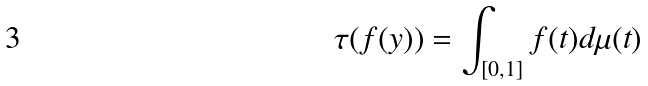<formula> <loc_0><loc_0><loc_500><loc_500>\tau ( f ( y ) ) = \int _ { [ 0 , 1 ] } f ( t ) d \mu ( t )</formula> 